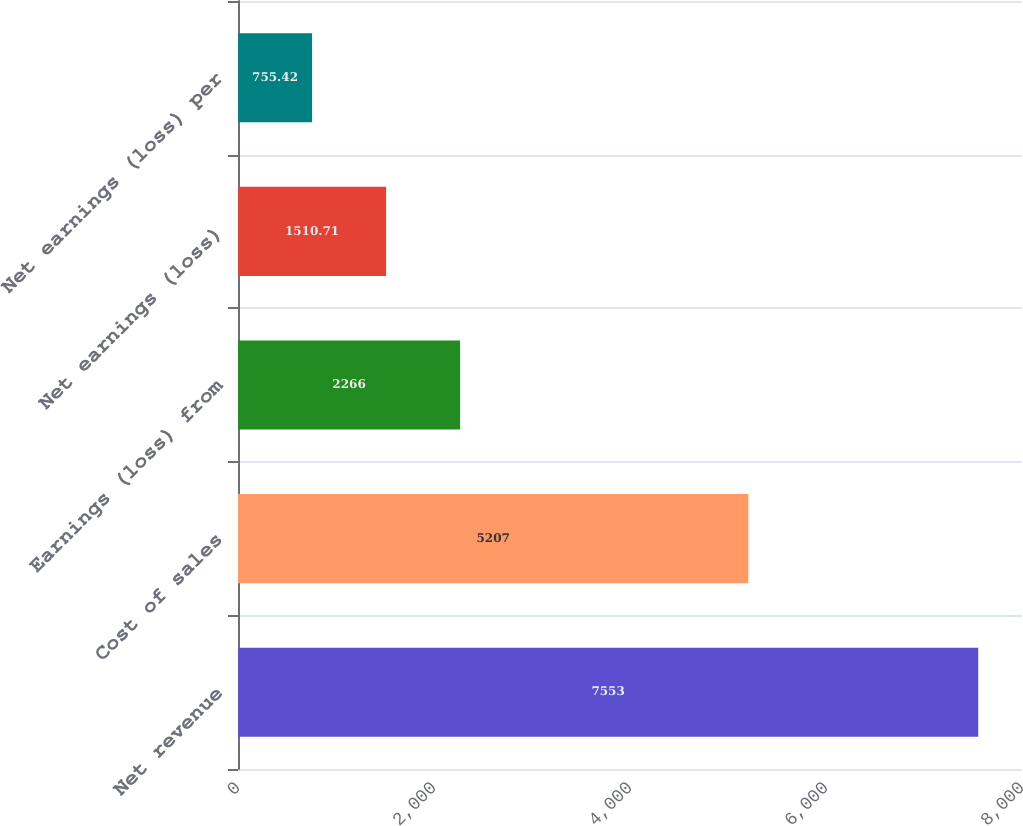Convert chart to OTSL. <chart><loc_0><loc_0><loc_500><loc_500><bar_chart><fcel>Net revenue<fcel>Cost of sales<fcel>Earnings (loss) from<fcel>Net earnings (loss)<fcel>Net earnings (loss) per<nl><fcel>7553<fcel>5207<fcel>2266<fcel>1510.71<fcel>755.42<nl></chart> 